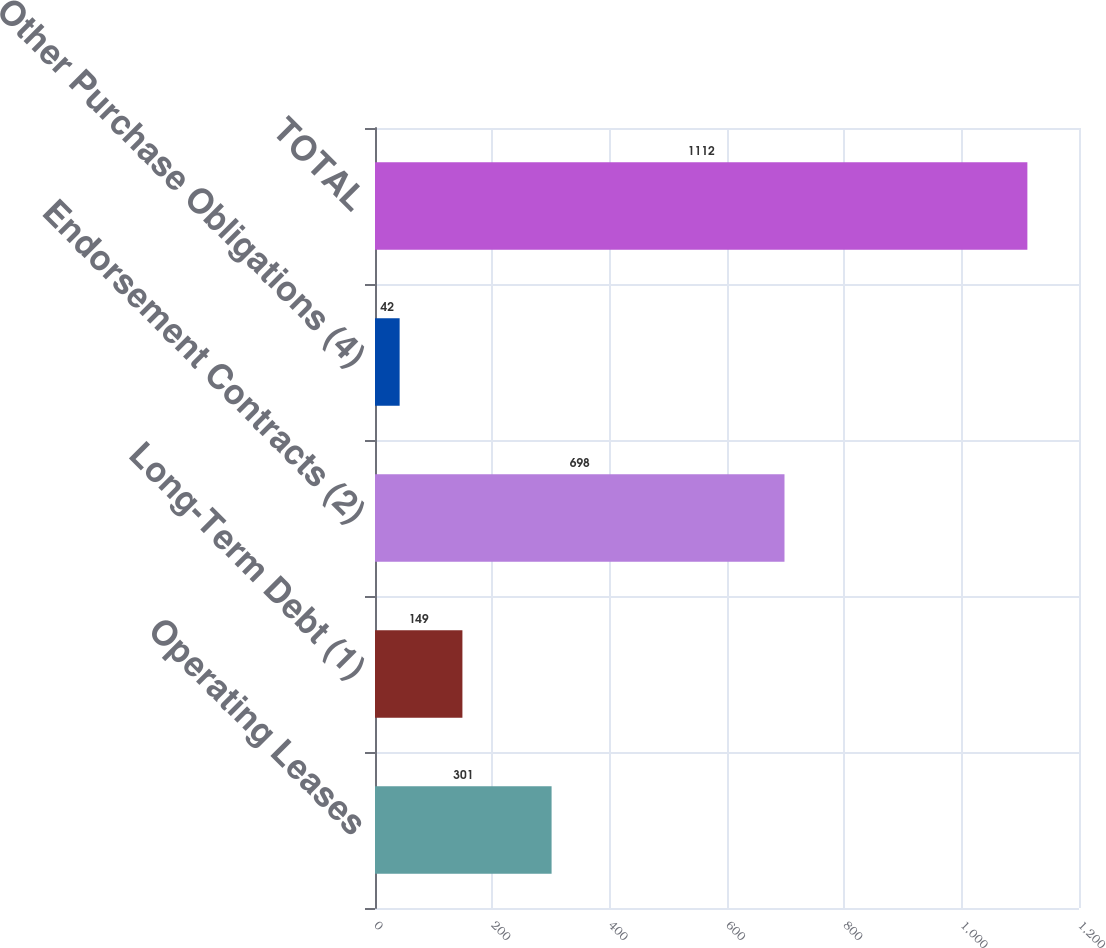<chart> <loc_0><loc_0><loc_500><loc_500><bar_chart><fcel>Operating Leases<fcel>Long-Term Debt (1)<fcel>Endorsement Contracts (2)<fcel>Other Purchase Obligations (4)<fcel>TOTAL<nl><fcel>301<fcel>149<fcel>698<fcel>42<fcel>1112<nl></chart> 